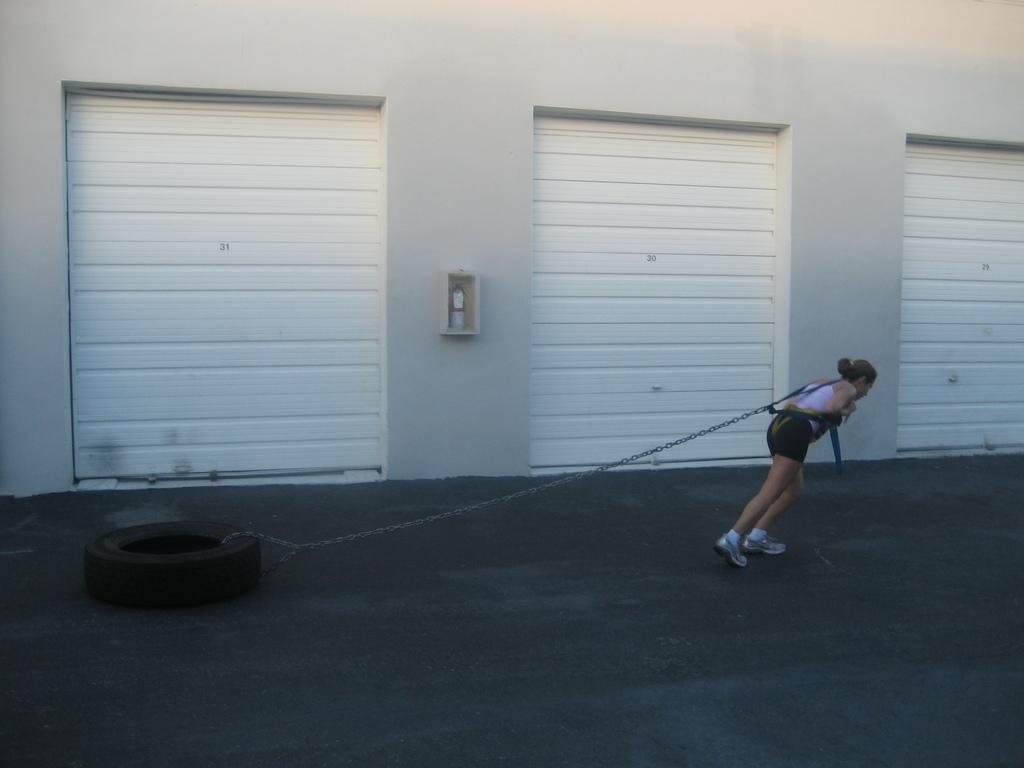In one or two sentences, can you explain what this image depicts? In this picture I can see a woman trying to pull a tyre with the help of a metal chain and and I can see few shutters. 